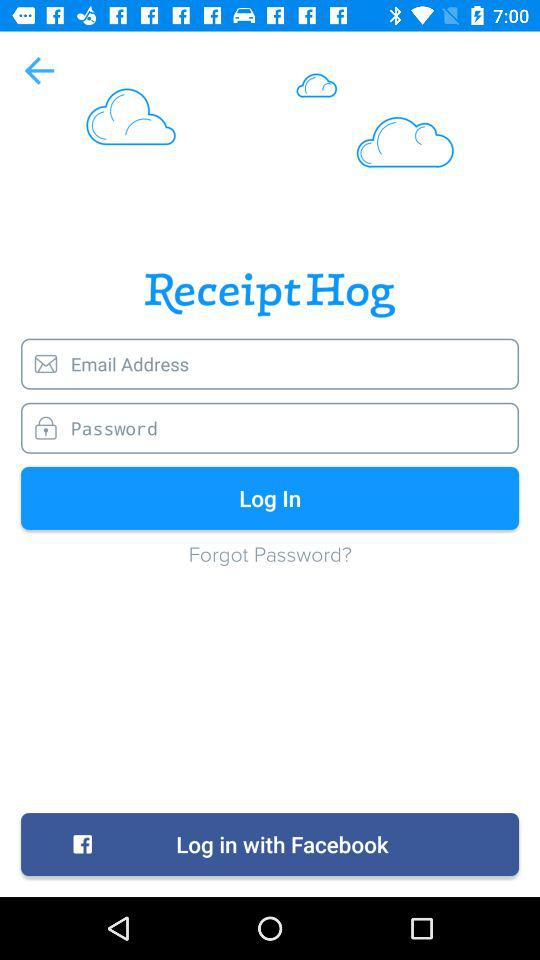Through what application can we log in? You can log in through "Facebook". 